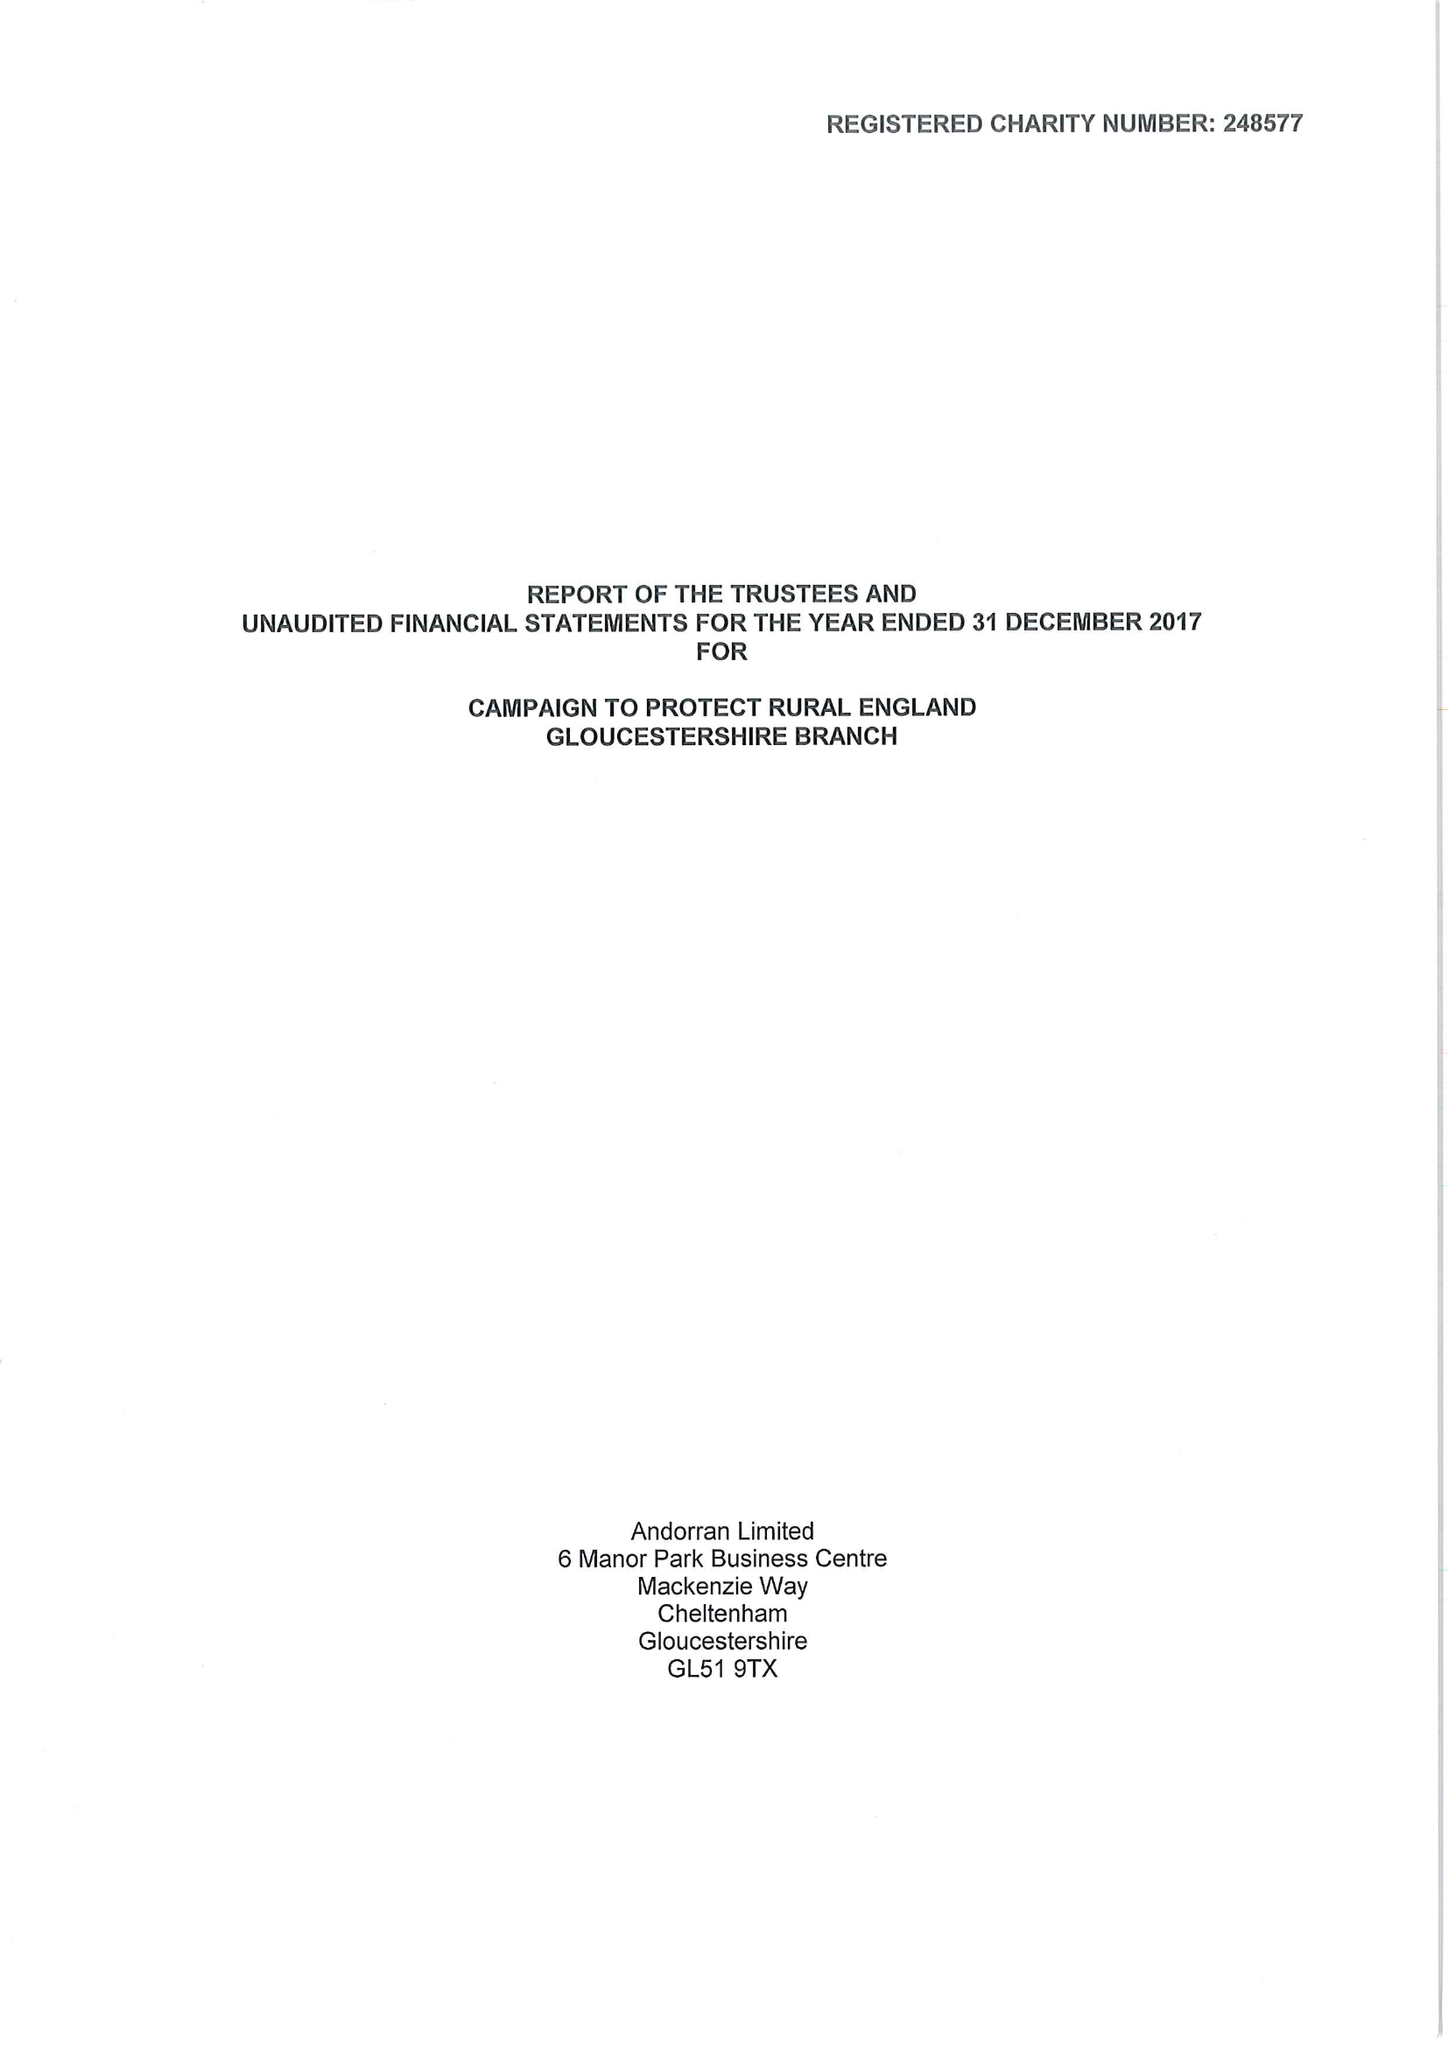What is the value for the address__postcode?
Answer the question using a single word or phrase. GL1 2LZ 